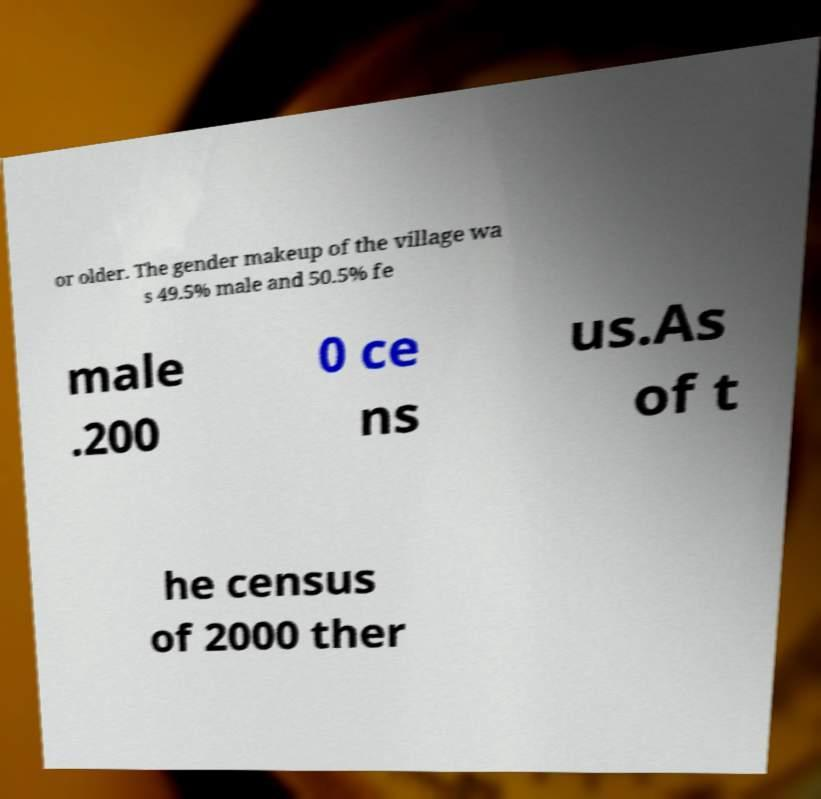Can you read and provide the text displayed in the image?This photo seems to have some interesting text. Can you extract and type it out for me? or older. The gender makeup of the village wa s 49.5% male and 50.5% fe male .200 0 ce ns us.As of t he census of 2000 ther 